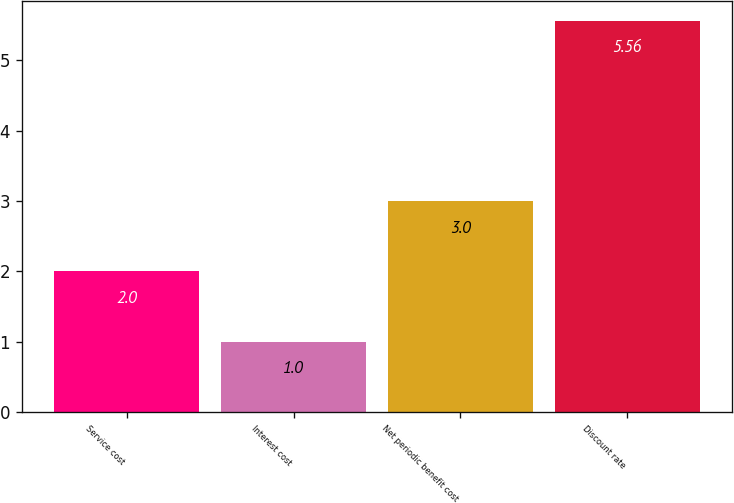Convert chart to OTSL. <chart><loc_0><loc_0><loc_500><loc_500><bar_chart><fcel>Service cost<fcel>Interest cost<fcel>Net periodic benefit cost<fcel>Discount rate<nl><fcel>2<fcel>1<fcel>3<fcel>5.56<nl></chart> 